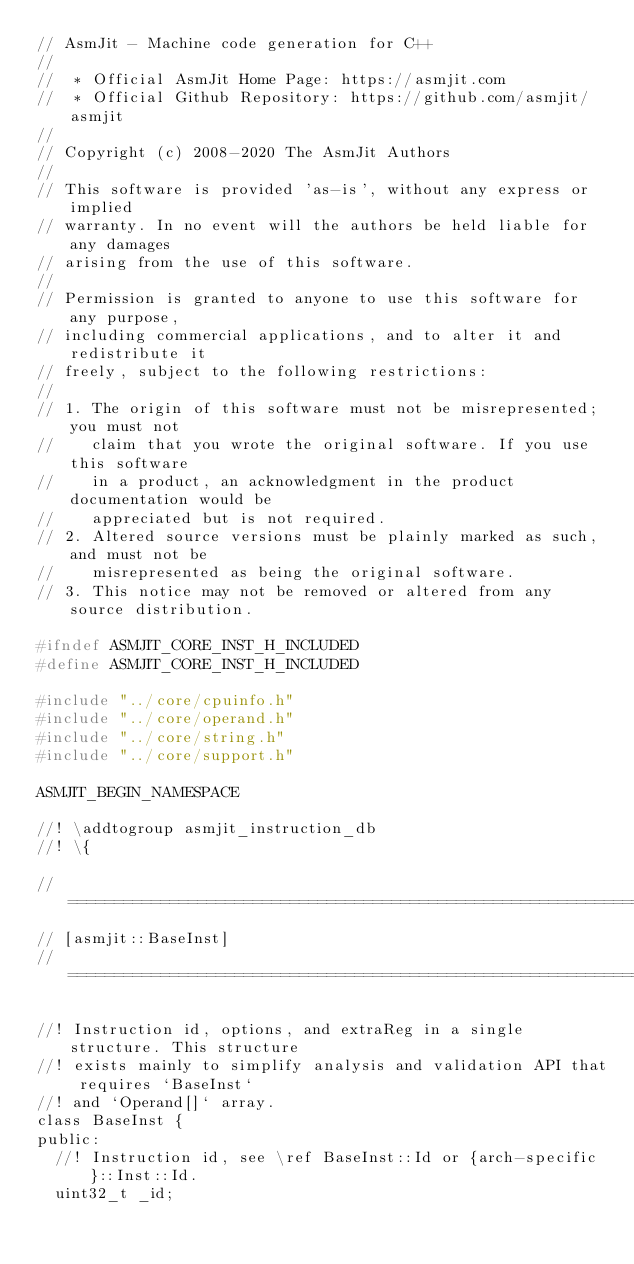Convert code to text. <code><loc_0><loc_0><loc_500><loc_500><_C_>// AsmJit - Machine code generation for C++
//
//  * Official AsmJit Home Page: https://asmjit.com
//  * Official Github Repository: https://github.com/asmjit/asmjit
//
// Copyright (c) 2008-2020 The AsmJit Authors
//
// This software is provided 'as-is', without any express or implied
// warranty. In no event will the authors be held liable for any damages
// arising from the use of this software.
//
// Permission is granted to anyone to use this software for any purpose,
// including commercial applications, and to alter it and redistribute it
// freely, subject to the following restrictions:
//
// 1. The origin of this software must not be misrepresented; you must not
//    claim that you wrote the original software. If you use this software
//    in a product, an acknowledgment in the product documentation would be
//    appreciated but is not required.
// 2. Altered source versions must be plainly marked as such, and must not be
//    misrepresented as being the original software.
// 3. This notice may not be removed or altered from any source distribution.

#ifndef ASMJIT_CORE_INST_H_INCLUDED
#define ASMJIT_CORE_INST_H_INCLUDED

#include "../core/cpuinfo.h"
#include "../core/operand.h"
#include "../core/string.h"
#include "../core/support.h"

ASMJIT_BEGIN_NAMESPACE

//! \addtogroup asmjit_instruction_db
//! \{

// ============================================================================
// [asmjit::BaseInst]
// ============================================================================

//! Instruction id, options, and extraReg in a single structure. This structure
//! exists mainly to simplify analysis and validation API that requires `BaseInst`
//! and `Operand[]` array.
class BaseInst {
public:
  //! Instruction id, see \ref BaseInst::Id or {arch-specific}::Inst::Id.
  uint32_t _id;</code> 